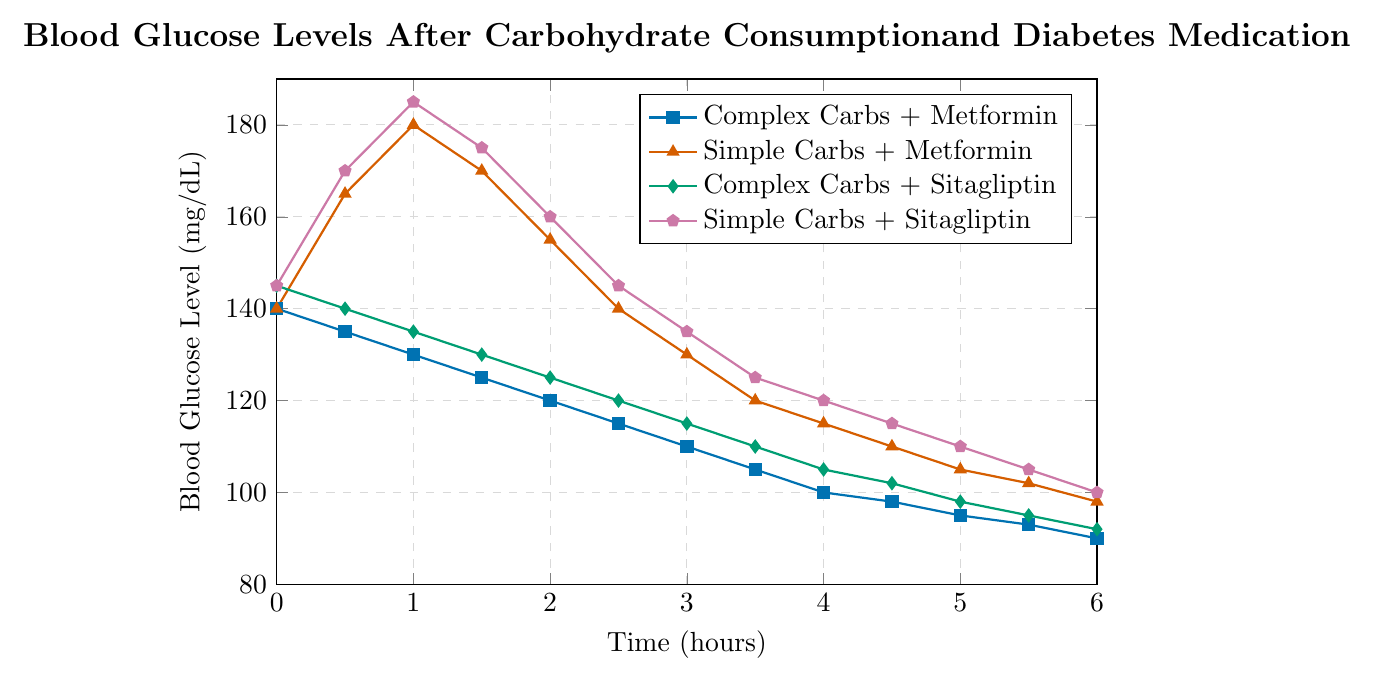What are the blood glucose levels for "Simple Carbs + Metformin" and "Complex Carbs + Metformin" at 1 hour? At 1 hour, the blood glucose level for "Simple Carbs + Metformin" is shown at 180 mg/dL, and for "Complex Carbs + Metformin" it is shown at 130 mg/dL.
Answer: 180 mg/dL for "Simple Carbs + Metformin" and 130 mg/dL for "Complex Carbs + Metformin" Between 1 and 2 hours, which group experienced the greatest decrease in blood glucose levels? Within the data points, the decrease for "Complex Carbs + Metformin" is from 130 to 120 (10 mg/dL), for "Simple Carbs + Metformin" is from 180 to 155 (25 mg/dL), for "Complex Carbs + Sitagliptin" is from 135 to 125 (10 mg/dL), and for "Simple Carbs + Sitagliptin" is from 185 to 160 (25 mg/dL). The greatest decrease is 25 mg/dL, observed in both "Simple Carbs + Metformin" and "Simple Carbs + Sitagliptin".
Answer: "Simple Carbs + Metformin" and "Simple Carbs + Sitagliptin" Which treatment combination shows the lowest blood glucose level at the 6-hour mark? Observing the blood glucose levels at the 6-hour mark:
"Complex Carbs + Metformin": 90 mg/dL, 
"Simple Carbs + Metformin": 98 mg/dL, 
"Complex Carbs + Sitagliptin": 92 mg/dL, 
"Simple Carbs + Sitagliptin": 100 mg/dL.
The lowest level is seen with "Complex Carbs + Metformin".
Answer: "Complex Carbs + Metformin" How does the blood glucose level for "Simple Carbs + Sitagliptin" change from the 2 hour to the 4 hour mark? At the 2-hour mark, the blood glucose level for "Simple Carbs + Sitagliptin" is 160 mg/dL. At the 4-hour mark, it is 120 mg/dL. The change is found by subtracting the value at 4 hours from the value at 2 hours: 160 - 120 = 40 mg/dL.
Answer: Decreases by 40 mg/dL What is the difference in blood glucose levels between "Complex Carbs + Sitagliptin" and "Simple Carbs + Metformin" at 3 hours? At 3 hours, the blood glucose level for "Complex Carbs + Sitagliptin" is 115 mg/dL, and for "Simple Carbs + Metformin" it is 130 mg/dL. The difference is calculated by subtracting the former from the latter: 130 - 115 = 15 mg/dL.
Answer: 15 mg/dL Among all treatments, which one shows the highest increase in blood glucose level within the first hour? The initial and 1-hour blood glucose levels:
"Complex Carbs + Metformin": 140 -> 130 (decreases by 10 mg/dL), 
"Simple Carbs + Metformin": 140 -> 180 (increases by 40 mg/dL),
"Complex Carbs + Sitagliptin": 145 -> 135 (decreases by 10 mg/dL), 
"Simple Carbs + Sitagliptin": 145 -> 185 (increases by 40 mg/dL).
The highest increase is observed with "Simple Carbs + Sitagliptin" at 40 mg/dL.
Answer: "Simple Carbs + Sitagliptin" By the 4-hour mark, which treatment shows the steadiest (least fluctuating) blood glucose levels? Assessing fluctuation by the changes in blood glucose levels:
"Complex Carbs + Metformin": drops from 140 mg/dL to 100 mg/dL (40 mg/dL),
"Simple Carbs + Metformin": rises from 140 mg/dL to 115 mg/dL (25 mg/dL up initially, then drops) 
"Complex Carbs + Sitagliptin": drops from 145 mg/dL to 105 mg/dL (40 mg/dL), 
"Simple Carbs + Sitagliptin": rises from 145 mg/dL to 120 mg/dL (40 mg/dL up initially, then drops). 
"Complex Carbs + Metformin" and "Complex Carbs + Sitagliptin" both have a 40 mg/dL range but more consistent drops, despite similar values, "Complex Carbs + Sitagliptin" is steadier due to its one-time drop without initial spikes.
Answer: "Complex Carbs + Sitagliptin" 